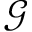<formula> <loc_0><loc_0><loc_500><loc_500>\mathcal { G }</formula> 